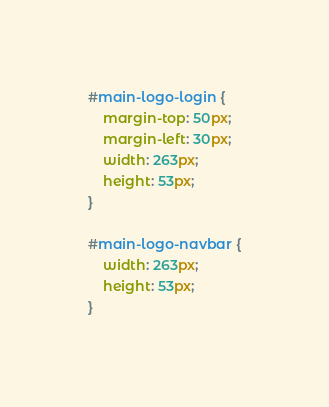Convert code to text. <code><loc_0><loc_0><loc_500><loc_500><_CSS_>#main-logo-login {
    margin-top: 50px;
    margin-left: 30px;
    width: 263px;
    height: 53px;
}

#main-logo-navbar {
    width: 263px;
    height: 53px;
}</code> 